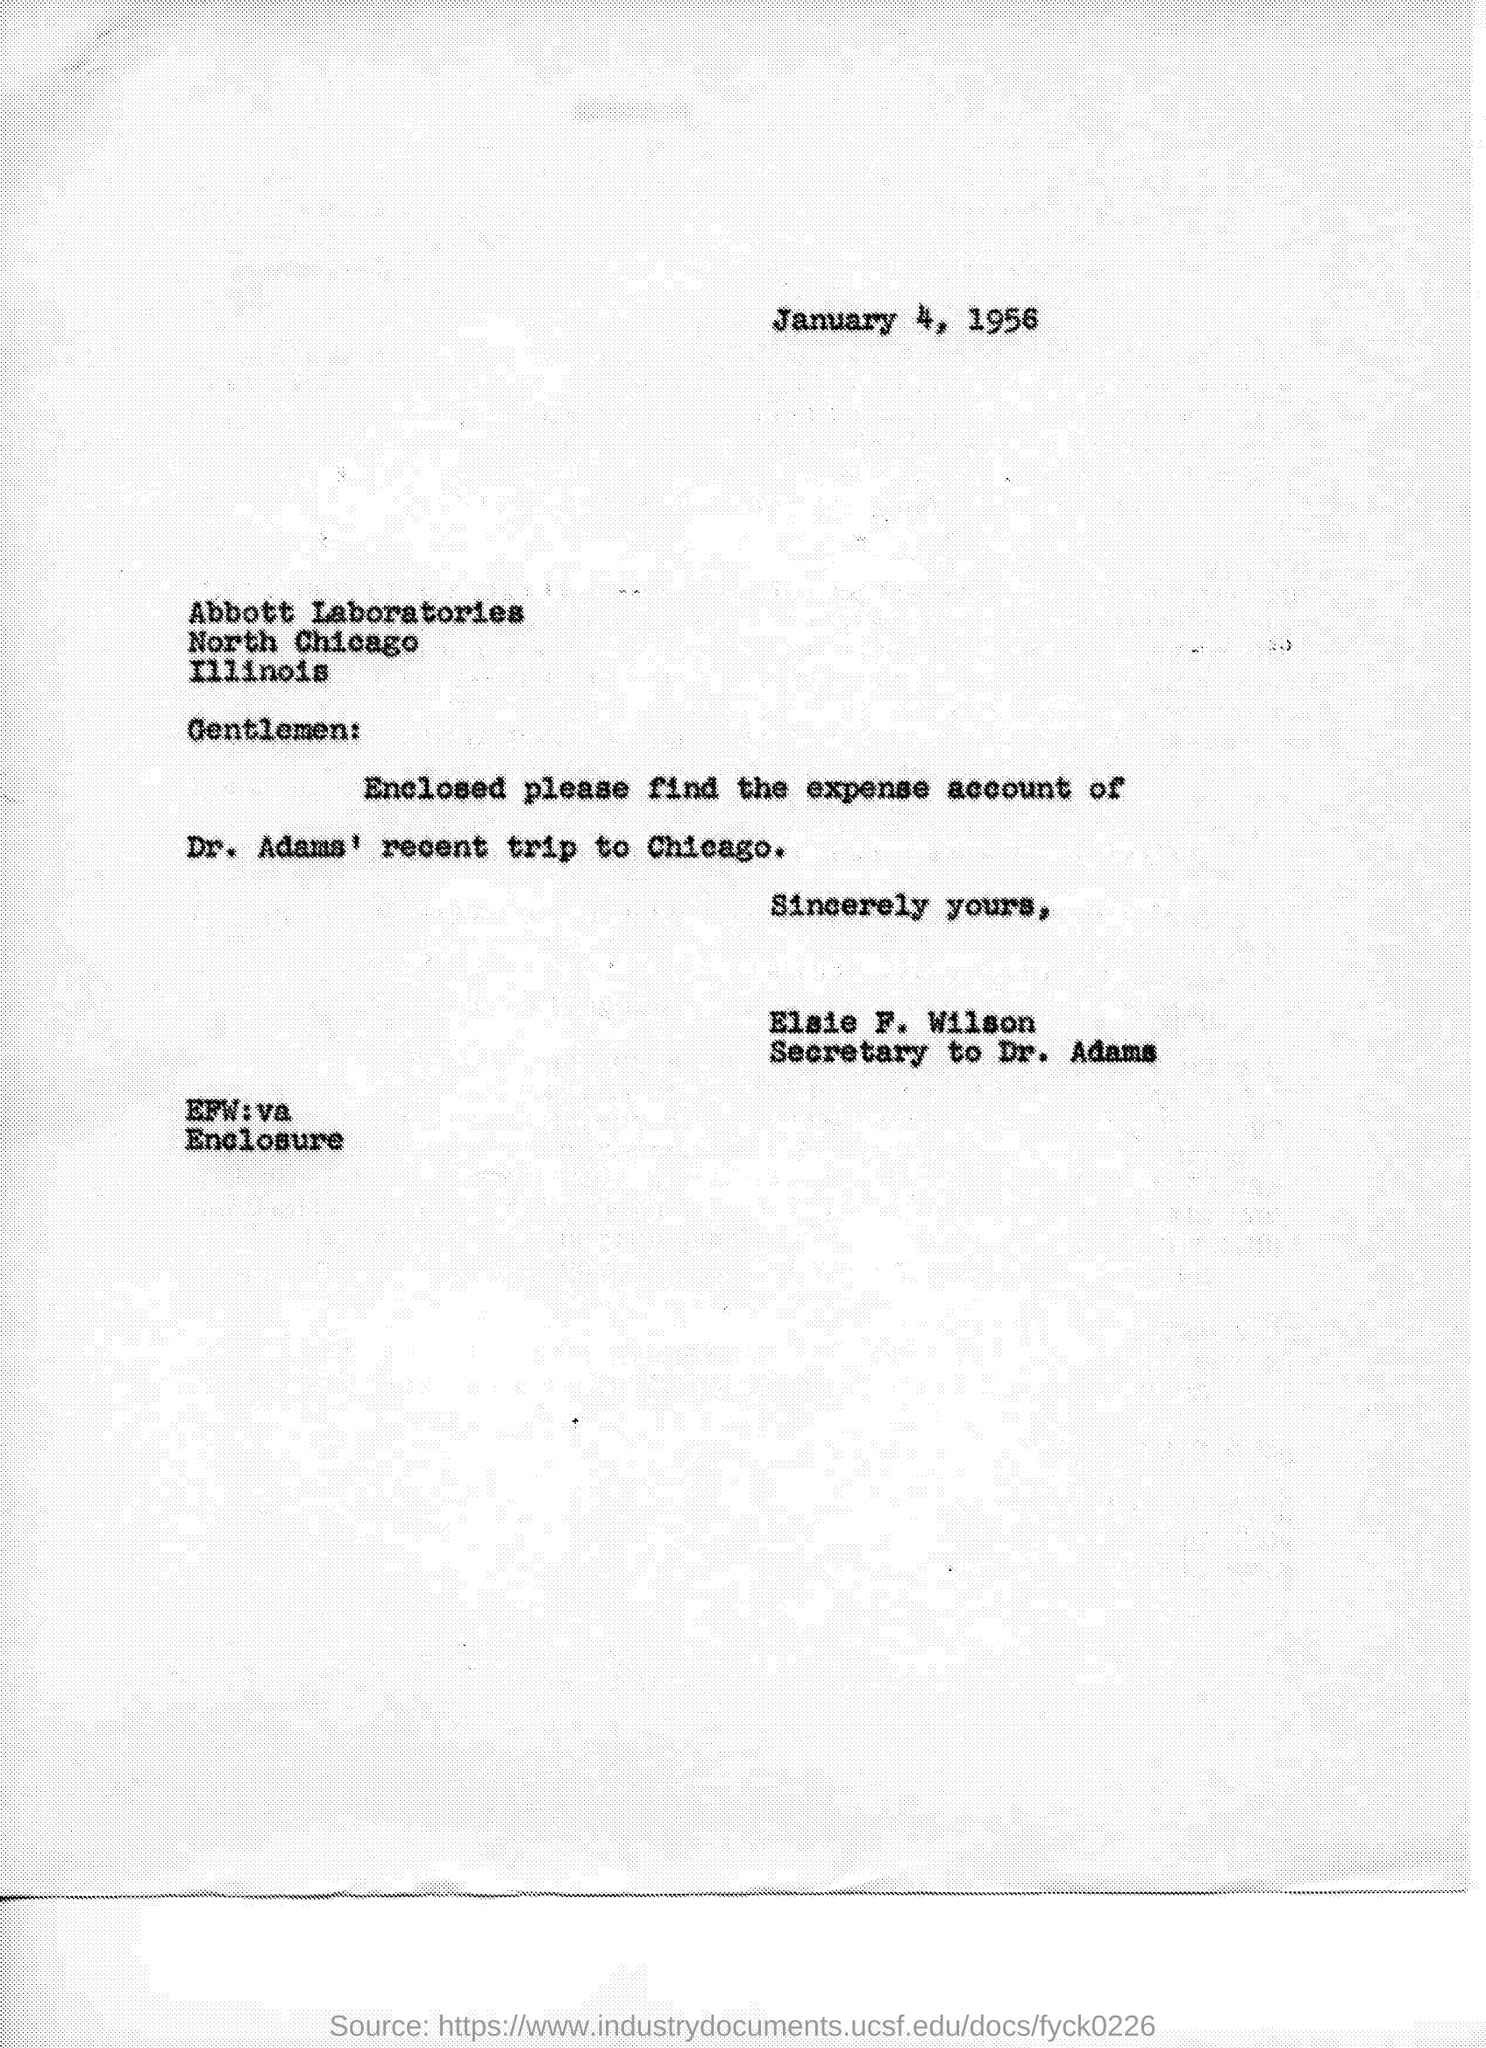What is the date on the document?
Give a very brief answer. January 4, 1956. To Whom is this letter addressed to?
Ensure brevity in your answer.  Abbott Laboratories. Who is this letter from?
Your answer should be compact. Elsie F. Wilson. Enclosed is the expense account of whose trip to Chicago?
Offer a very short reply. Dr. Adams. 